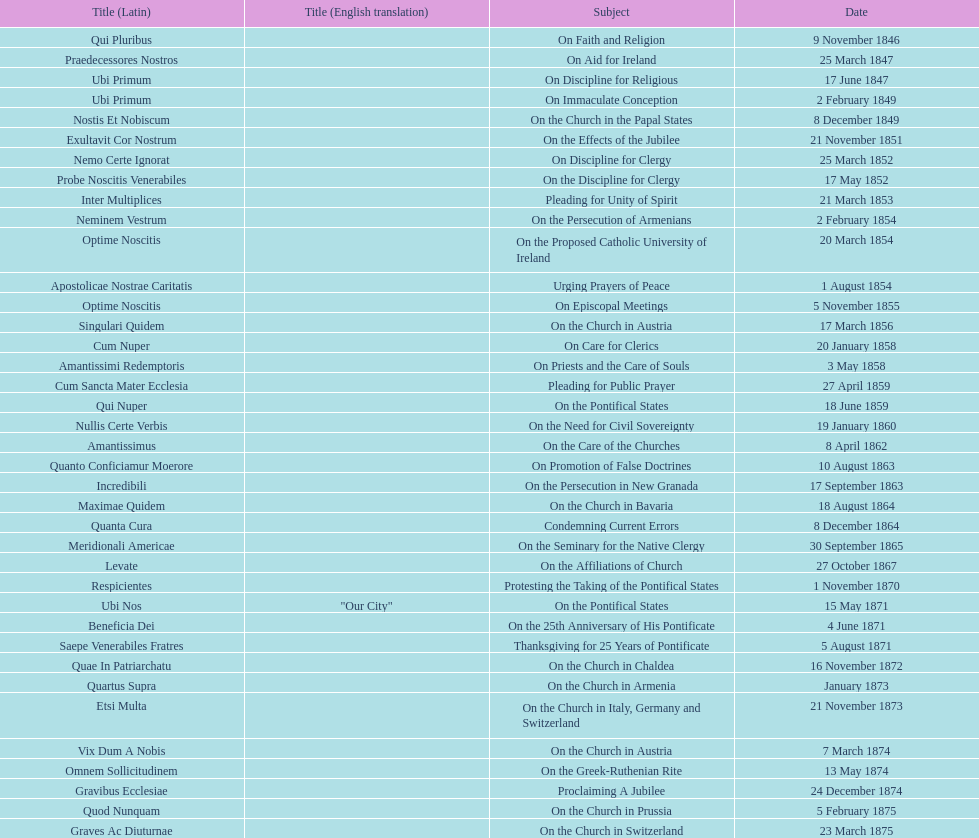What was the regularity of encyclical releases in january? 3. Could you parse the entire table as a dict? {'header': ['Title (Latin)', 'Title (English translation)', 'Subject', 'Date'], 'rows': [['Qui Pluribus', '', 'On Faith and Religion', '9 November 1846'], ['Praedecessores Nostros', '', 'On Aid for Ireland', '25 March 1847'], ['Ubi Primum', '', 'On Discipline for Religious', '17 June 1847'], ['Ubi Primum', '', 'On Immaculate Conception', '2 February 1849'], ['Nostis Et Nobiscum', '', 'On the Church in the Papal States', '8 December 1849'], ['Exultavit Cor Nostrum', '', 'On the Effects of the Jubilee', '21 November 1851'], ['Nemo Certe Ignorat', '', 'On Discipline for Clergy', '25 March 1852'], ['Probe Noscitis Venerabiles', '', 'On the Discipline for Clergy', '17 May 1852'], ['Inter Multiplices', '', 'Pleading for Unity of Spirit', '21 March 1853'], ['Neminem Vestrum', '', 'On the Persecution of Armenians', '2 February 1854'], ['Optime Noscitis', '', 'On the Proposed Catholic University of Ireland', '20 March 1854'], ['Apostolicae Nostrae Caritatis', '', 'Urging Prayers of Peace', '1 August 1854'], ['Optime Noscitis', '', 'On Episcopal Meetings', '5 November 1855'], ['Singulari Quidem', '', 'On the Church in Austria', '17 March 1856'], ['Cum Nuper', '', 'On Care for Clerics', '20 January 1858'], ['Amantissimi Redemptoris', '', 'On Priests and the Care of Souls', '3 May 1858'], ['Cum Sancta Mater Ecclesia', '', 'Pleading for Public Prayer', '27 April 1859'], ['Qui Nuper', '', 'On the Pontifical States', '18 June 1859'], ['Nullis Certe Verbis', '', 'On the Need for Civil Sovereignty', '19 January 1860'], ['Amantissimus', '', 'On the Care of the Churches', '8 April 1862'], ['Quanto Conficiamur Moerore', '', 'On Promotion of False Doctrines', '10 August 1863'], ['Incredibili', '', 'On the Persecution in New Granada', '17 September 1863'], ['Maximae Quidem', '', 'On the Church in Bavaria', '18 August 1864'], ['Quanta Cura', '', 'Condemning Current Errors', '8 December 1864'], ['Meridionali Americae', '', 'On the Seminary for the Native Clergy', '30 September 1865'], ['Levate', '', 'On the Affiliations of Church', '27 October 1867'], ['Respicientes', '', 'Protesting the Taking of the Pontifical States', '1 November 1870'], ['Ubi Nos', '"Our City"', 'On the Pontifical States', '15 May 1871'], ['Beneficia Dei', '', 'On the 25th Anniversary of His Pontificate', '4 June 1871'], ['Saepe Venerabiles Fratres', '', 'Thanksgiving for 25 Years of Pontificate', '5 August 1871'], ['Quae In Patriarchatu', '', 'On the Church in Chaldea', '16 November 1872'], ['Quartus Supra', '', 'On the Church in Armenia', 'January 1873'], ['Etsi Multa', '', 'On the Church in Italy, Germany and Switzerland', '21 November 1873'], ['Vix Dum A Nobis', '', 'On the Church in Austria', '7 March 1874'], ['Omnem Sollicitudinem', '', 'On the Greek-Ruthenian Rite', '13 May 1874'], ['Gravibus Ecclesiae', '', 'Proclaiming A Jubilee', '24 December 1874'], ['Quod Nunquam', '', 'On the Church in Prussia', '5 February 1875'], ['Graves Ac Diuturnae', '', 'On the Church in Switzerland', '23 March 1875']]} 